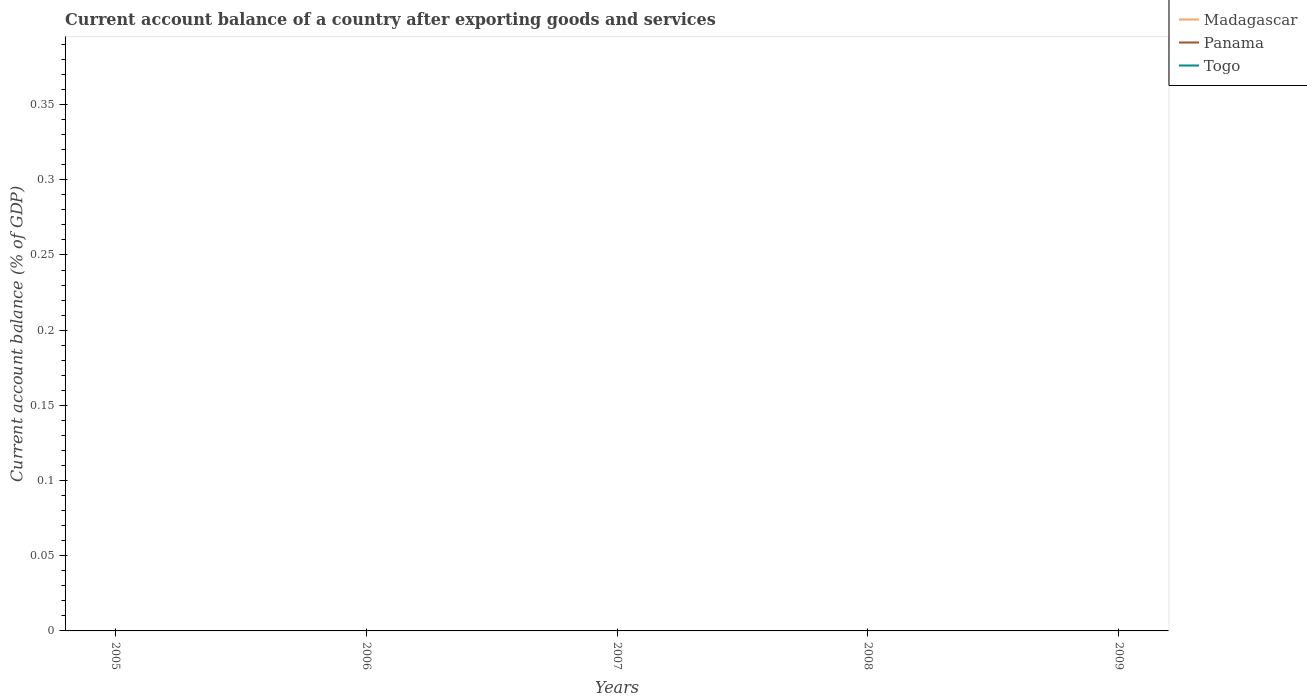Does the line corresponding to Togo intersect with the line corresponding to Madagascar?
Your answer should be very brief. No. Is the account balance in Panama strictly greater than the account balance in Madagascar over the years?
Ensure brevity in your answer.  No. How many years are there in the graph?
Make the answer very short. 5. Are the values on the major ticks of Y-axis written in scientific E-notation?
Offer a terse response. No. Does the graph contain grids?
Provide a succinct answer. No. What is the title of the graph?
Your answer should be compact. Current account balance of a country after exporting goods and services. Does "Monaco" appear as one of the legend labels in the graph?
Your response must be concise. No. What is the label or title of the X-axis?
Your answer should be very brief. Years. What is the label or title of the Y-axis?
Provide a succinct answer. Current account balance (% of GDP). What is the Current account balance (% of GDP) of Madagascar in 2005?
Make the answer very short. 0. What is the Current account balance (% of GDP) of Madagascar in 2006?
Offer a terse response. 0. What is the Current account balance (% of GDP) in Panama in 2006?
Offer a terse response. 0. What is the Current account balance (% of GDP) in Madagascar in 2008?
Give a very brief answer. 0. What is the Current account balance (% of GDP) of Panama in 2008?
Give a very brief answer. 0. What is the Current account balance (% of GDP) of Madagascar in 2009?
Provide a short and direct response. 0. What is the Current account balance (% of GDP) of Panama in 2009?
Provide a succinct answer. 0. What is the average Current account balance (% of GDP) in Madagascar per year?
Offer a very short reply. 0. What is the average Current account balance (% of GDP) in Panama per year?
Keep it short and to the point. 0. What is the average Current account balance (% of GDP) in Togo per year?
Make the answer very short. 0. 